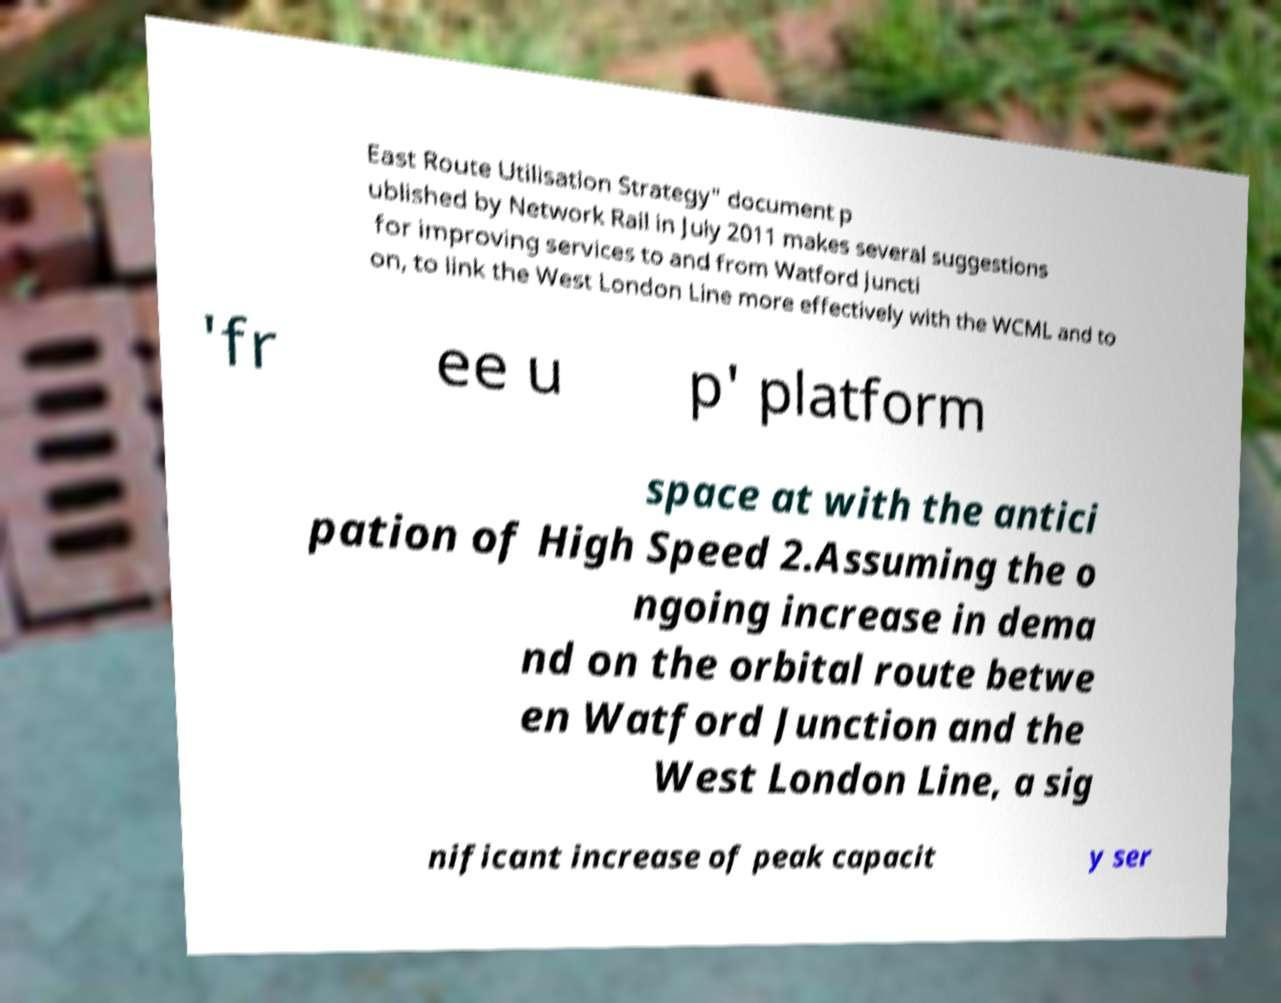Please read and relay the text visible in this image. What does it say? East Route Utilisation Strategy" document p ublished by Network Rail in July 2011 makes several suggestions for improving services to and from Watford Juncti on, to link the West London Line more effectively with the WCML and to 'fr ee u p' platform space at with the antici pation of High Speed 2.Assuming the o ngoing increase in dema nd on the orbital route betwe en Watford Junction and the West London Line, a sig nificant increase of peak capacit y ser 